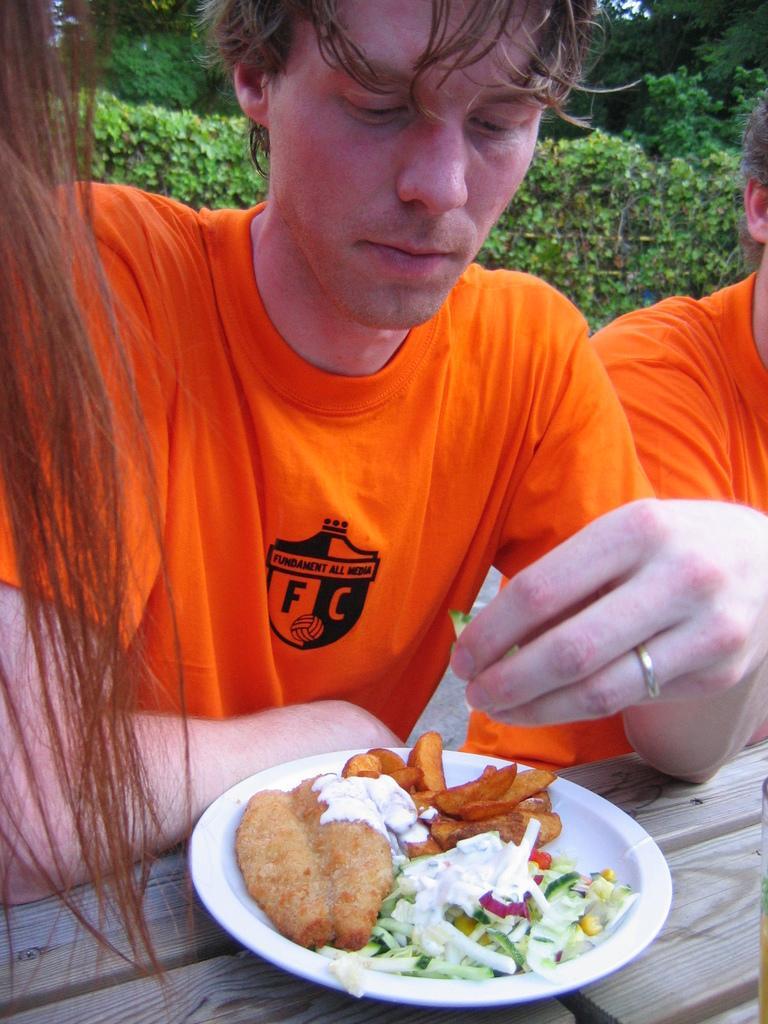In one or two sentences, can you explain what this image depicts? In this image we can see hair of a person on the left corner. There is a table at the bottom. There is a person and food item on the plate in the foreground. There is a person with orange shirt on the right corner. There are trees in the background. 